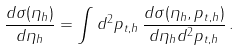<formula> <loc_0><loc_0><loc_500><loc_500>\frac { d \sigma ( \eta _ { h } ) } { d \eta _ { h } } = \int d ^ { 2 } p _ { t , h } \, \frac { d \sigma ( \eta _ { h } , p _ { t , h } ) } { d \eta _ { h } d ^ { 2 } p _ { t , h } } \, .</formula> 